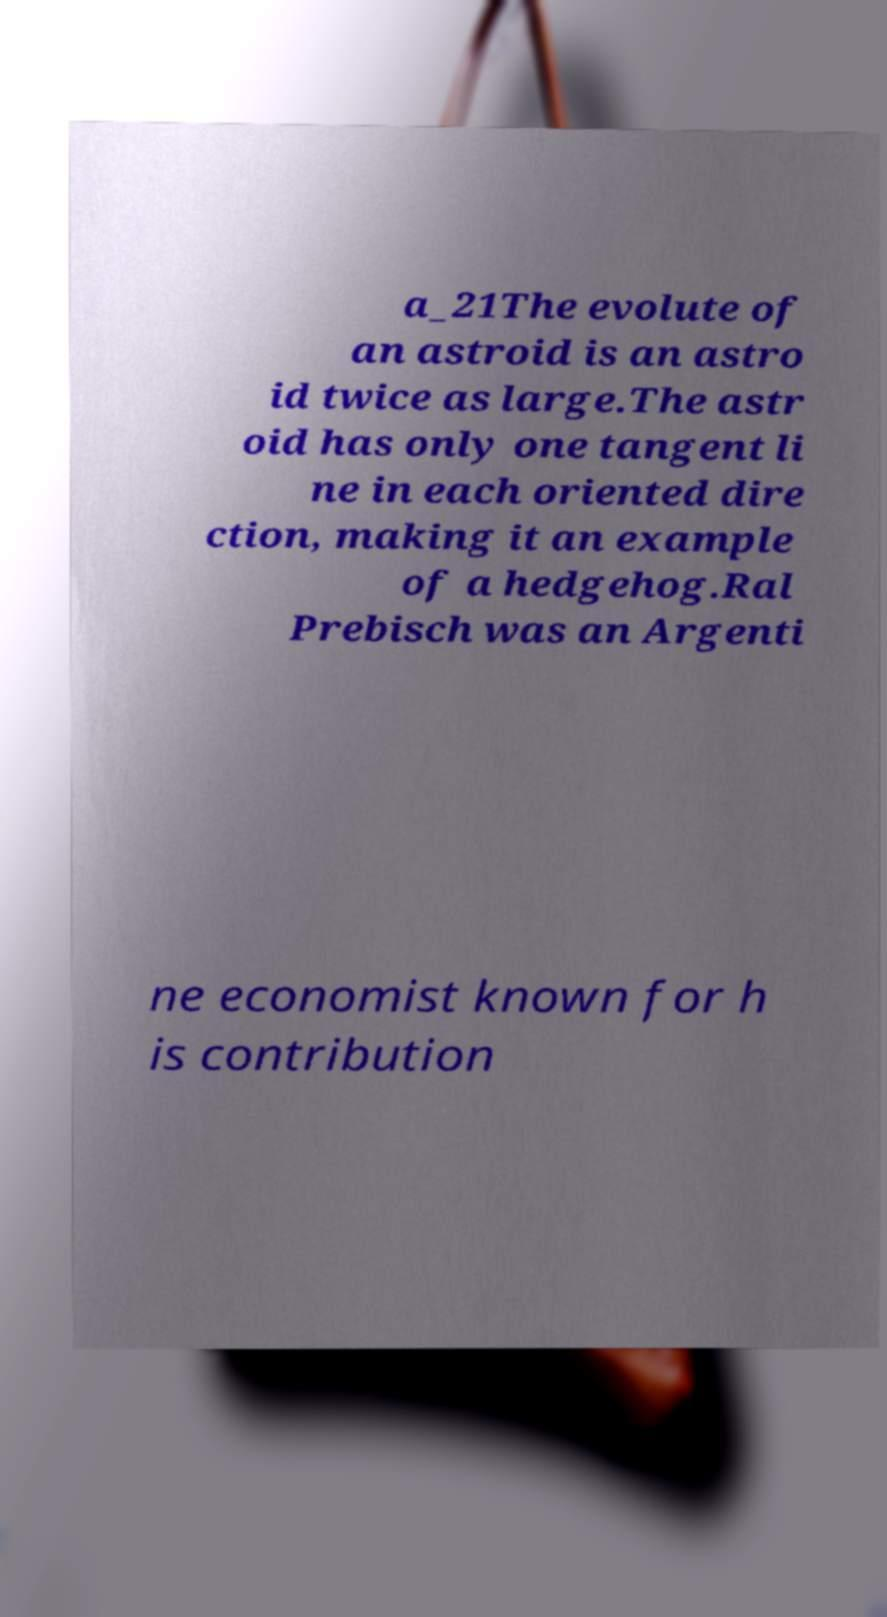For documentation purposes, I need the text within this image transcribed. Could you provide that? a_21The evolute of an astroid is an astro id twice as large.The astr oid has only one tangent li ne in each oriented dire ction, making it an example of a hedgehog.Ral Prebisch was an Argenti ne economist known for h is contribution 